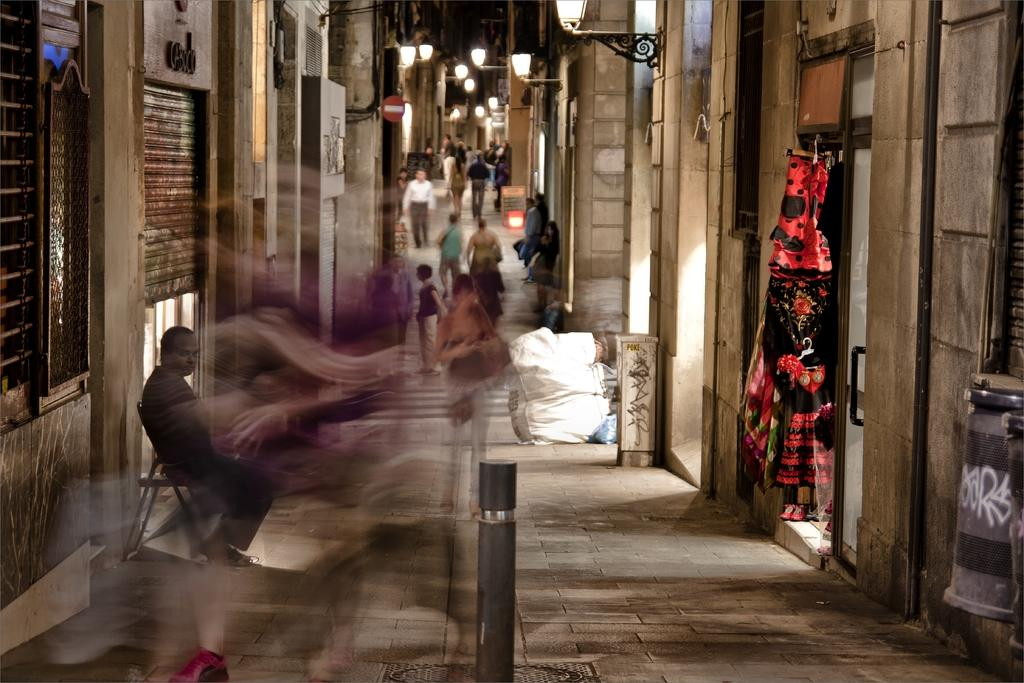What are the people in the image doing? There are persons standing on the road in the image. Can you describe the position of the man in the image? There is a man sitting on a chair in the image. What type of structures can be seen in the image? There are buildings visible in the image. What is the source of illumination in the image? There are lights present in the image. What type of vacation is the man planning based on the image? There is no indication in the image that the man is planning a vacation, so it cannot be determined from the picture. 